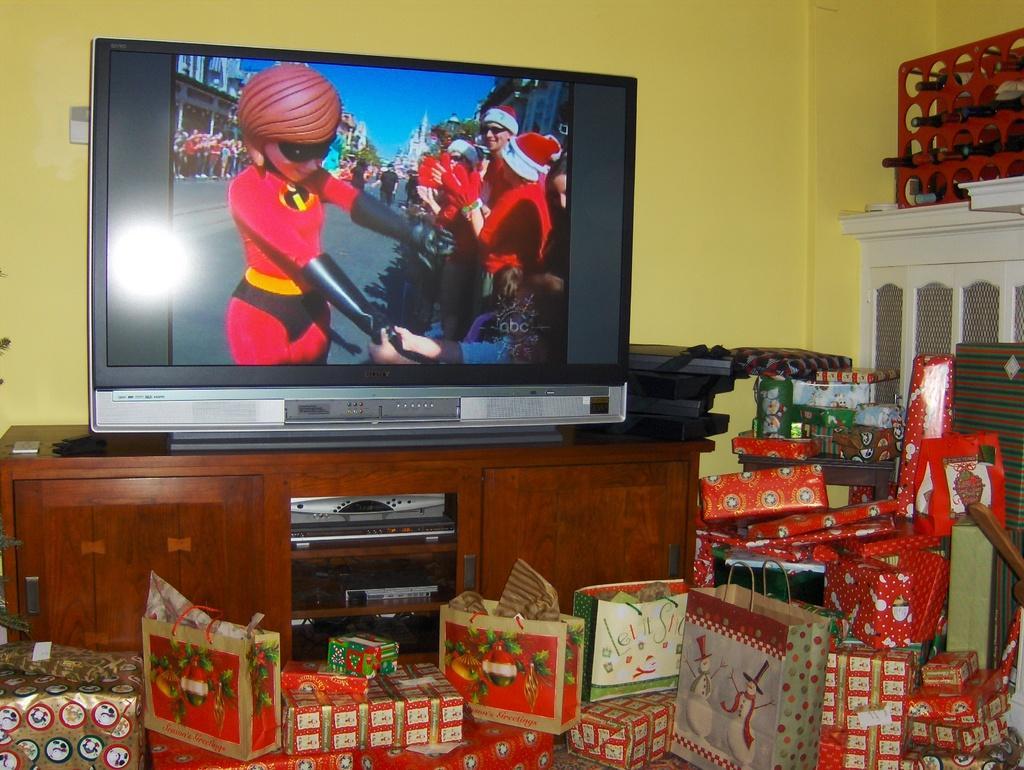Can you describe this image briefly? There is a wooden table with racks. On the table there is a television. Also some other items. On the racks there are electronics devices. In front of the table there are many gift packets. In the back there is a wall. 